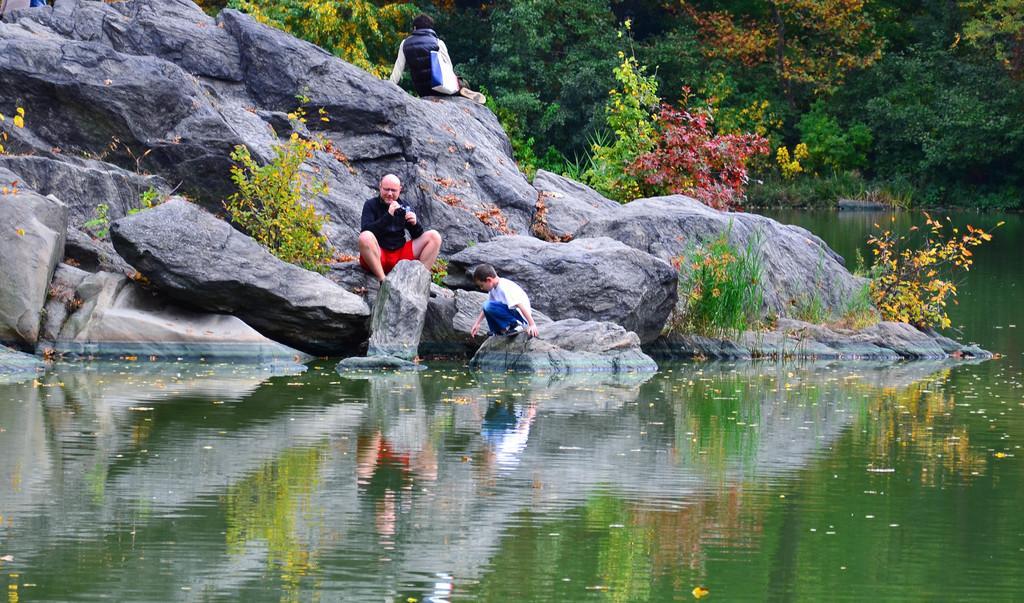Describe this image in one or two sentences. In this image we can see people sitting on the rocks and we can also see plants, trees and water. 